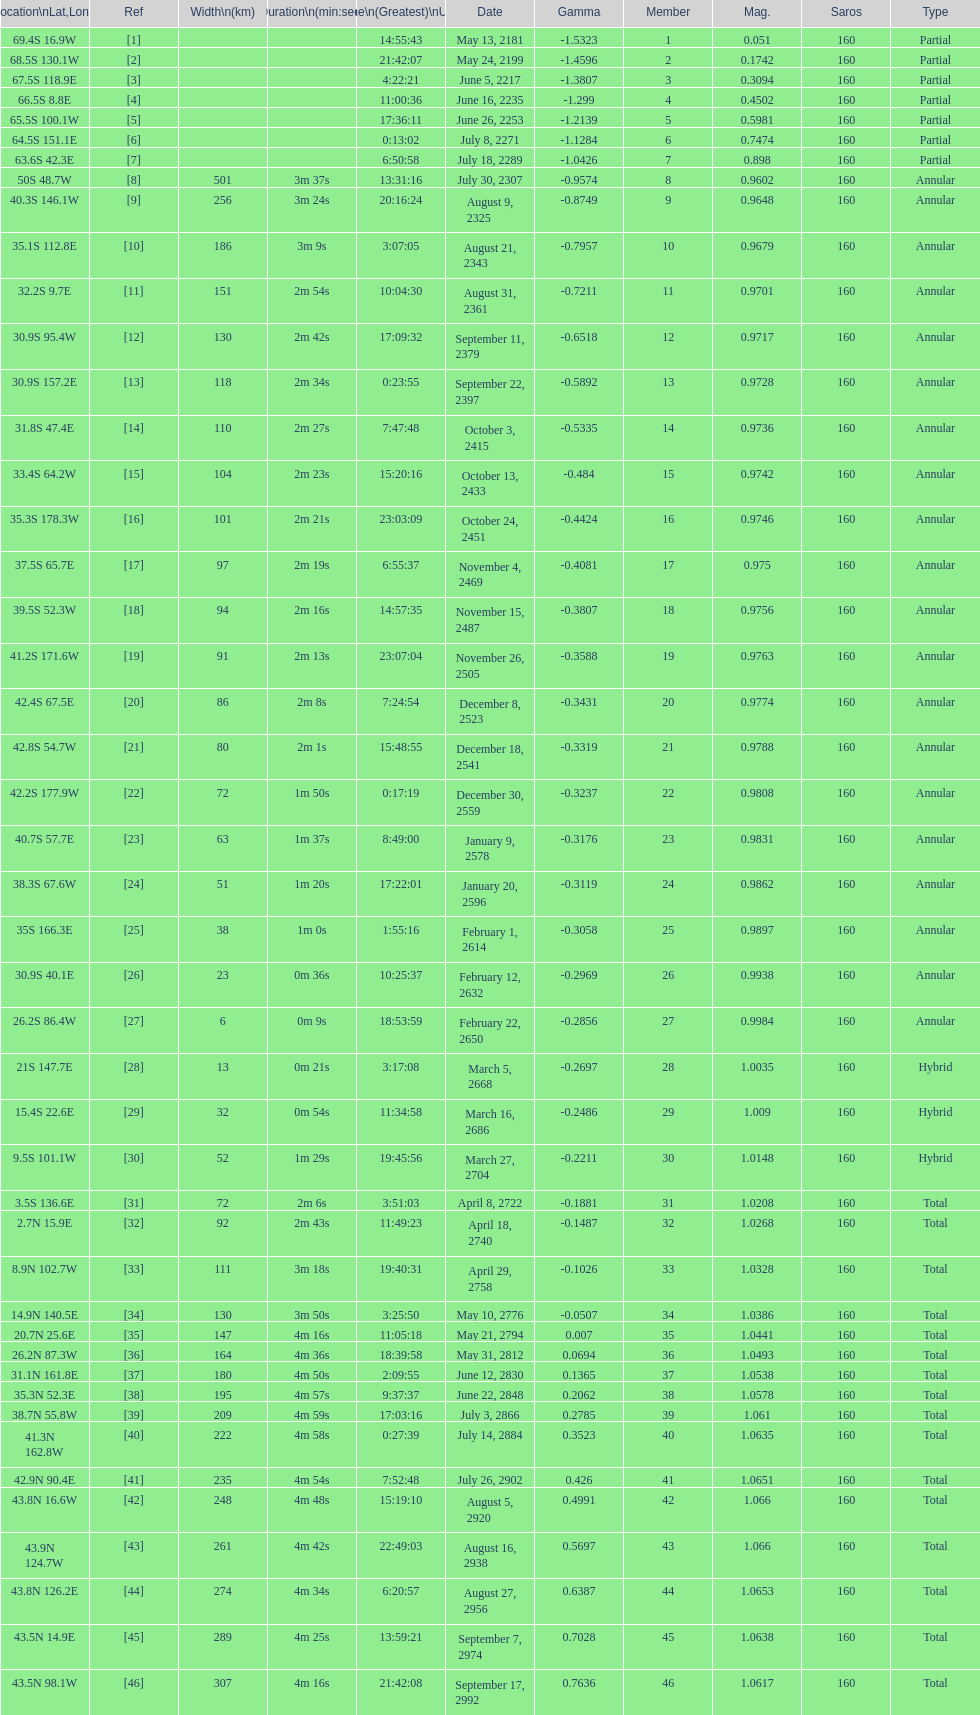Parse the full table. {'header': ['Location\\nLat,Long', 'Ref', 'Width\\n(km)', 'Duration\\n(min:sec)', 'Time\\n(Greatest)\\nUTC', 'Date', 'Gamma', 'Member', 'Mag.', 'Saros', 'Type'], 'rows': [['69.4S 16.9W', '[1]', '', '', '14:55:43', 'May 13, 2181', '-1.5323', '1', '0.051', '160', 'Partial'], ['68.5S 130.1W', '[2]', '', '', '21:42:07', 'May 24, 2199', '-1.4596', '2', '0.1742', '160', 'Partial'], ['67.5S 118.9E', '[3]', '', '', '4:22:21', 'June 5, 2217', '-1.3807', '3', '0.3094', '160', 'Partial'], ['66.5S 8.8E', '[4]', '', '', '11:00:36', 'June 16, 2235', '-1.299', '4', '0.4502', '160', 'Partial'], ['65.5S 100.1W', '[5]', '', '', '17:36:11', 'June 26, 2253', '-1.2139', '5', '0.5981', '160', 'Partial'], ['64.5S 151.1E', '[6]', '', '', '0:13:02', 'July 8, 2271', '-1.1284', '6', '0.7474', '160', 'Partial'], ['63.6S 42.3E', '[7]', '', '', '6:50:58', 'July 18, 2289', '-1.0426', '7', '0.898', '160', 'Partial'], ['50S 48.7W', '[8]', '501', '3m 37s', '13:31:16', 'July 30, 2307', '-0.9574', '8', '0.9602', '160', 'Annular'], ['40.3S 146.1W', '[9]', '256', '3m 24s', '20:16:24', 'August 9, 2325', '-0.8749', '9', '0.9648', '160', 'Annular'], ['35.1S 112.8E', '[10]', '186', '3m 9s', '3:07:05', 'August 21, 2343', '-0.7957', '10', '0.9679', '160', 'Annular'], ['32.2S 9.7E', '[11]', '151', '2m 54s', '10:04:30', 'August 31, 2361', '-0.7211', '11', '0.9701', '160', 'Annular'], ['30.9S 95.4W', '[12]', '130', '2m 42s', '17:09:32', 'September 11, 2379', '-0.6518', '12', '0.9717', '160', 'Annular'], ['30.9S 157.2E', '[13]', '118', '2m 34s', '0:23:55', 'September 22, 2397', '-0.5892', '13', '0.9728', '160', 'Annular'], ['31.8S 47.4E', '[14]', '110', '2m 27s', '7:47:48', 'October 3, 2415', '-0.5335', '14', '0.9736', '160', 'Annular'], ['33.4S 64.2W', '[15]', '104', '2m 23s', '15:20:16', 'October 13, 2433', '-0.484', '15', '0.9742', '160', 'Annular'], ['35.3S 178.3W', '[16]', '101', '2m 21s', '23:03:09', 'October 24, 2451', '-0.4424', '16', '0.9746', '160', 'Annular'], ['37.5S 65.7E', '[17]', '97', '2m 19s', '6:55:37', 'November 4, 2469', '-0.4081', '17', '0.975', '160', 'Annular'], ['39.5S 52.3W', '[18]', '94', '2m 16s', '14:57:35', 'November 15, 2487', '-0.3807', '18', '0.9756', '160', 'Annular'], ['41.2S 171.6W', '[19]', '91', '2m 13s', '23:07:04', 'November 26, 2505', '-0.3588', '19', '0.9763', '160', 'Annular'], ['42.4S 67.5E', '[20]', '86', '2m 8s', '7:24:54', 'December 8, 2523', '-0.3431', '20', '0.9774', '160', 'Annular'], ['42.8S 54.7W', '[21]', '80', '2m 1s', '15:48:55', 'December 18, 2541', '-0.3319', '21', '0.9788', '160', 'Annular'], ['42.2S 177.9W', '[22]', '72', '1m 50s', '0:17:19', 'December 30, 2559', '-0.3237', '22', '0.9808', '160', 'Annular'], ['40.7S 57.7E', '[23]', '63', '1m 37s', '8:49:00', 'January 9, 2578', '-0.3176', '23', '0.9831', '160', 'Annular'], ['38.3S 67.6W', '[24]', '51', '1m 20s', '17:22:01', 'January 20, 2596', '-0.3119', '24', '0.9862', '160', 'Annular'], ['35S 166.3E', '[25]', '38', '1m 0s', '1:55:16', 'February 1, 2614', '-0.3058', '25', '0.9897', '160', 'Annular'], ['30.9S 40.1E', '[26]', '23', '0m 36s', '10:25:37', 'February 12, 2632', '-0.2969', '26', '0.9938', '160', 'Annular'], ['26.2S 86.4W', '[27]', '6', '0m 9s', '18:53:59', 'February 22, 2650', '-0.2856', '27', '0.9984', '160', 'Annular'], ['21S 147.7E', '[28]', '13', '0m 21s', '3:17:08', 'March 5, 2668', '-0.2697', '28', '1.0035', '160', 'Hybrid'], ['15.4S 22.6E', '[29]', '32', '0m 54s', '11:34:58', 'March 16, 2686', '-0.2486', '29', '1.009', '160', 'Hybrid'], ['9.5S 101.1W', '[30]', '52', '1m 29s', '19:45:56', 'March 27, 2704', '-0.2211', '30', '1.0148', '160', 'Hybrid'], ['3.5S 136.6E', '[31]', '72', '2m 6s', '3:51:03', 'April 8, 2722', '-0.1881', '31', '1.0208', '160', 'Total'], ['2.7N 15.9E', '[32]', '92', '2m 43s', '11:49:23', 'April 18, 2740', '-0.1487', '32', '1.0268', '160', 'Total'], ['8.9N 102.7W', '[33]', '111', '3m 18s', '19:40:31', 'April 29, 2758', '-0.1026', '33', '1.0328', '160', 'Total'], ['14.9N 140.5E', '[34]', '130', '3m 50s', '3:25:50', 'May 10, 2776', '-0.0507', '34', '1.0386', '160', 'Total'], ['20.7N 25.6E', '[35]', '147', '4m 16s', '11:05:18', 'May 21, 2794', '0.007', '35', '1.0441', '160', 'Total'], ['26.2N 87.3W', '[36]', '164', '4m 36s', '18:39:58', 'May 31, 2812', '0.0694', '36', '1.0493', '160', 'Total'], ['31.1N 161.8E', '[37]', '180', '4m 50s', '2:09:55', 'June 12, 2830', '0.1365', '37', '1.0538', '160', 'Total'], ['35.3N 52.3E', '[38]', '195', '4m 57s', '9:37:37', 'June 22, 2848', '0.2062', '38', '1.0578', '160', 'Total'], ['38.7N 55.8W', '[39]', '209', '4m 59s', '17:03:16', 'July 3, 2866', '0.2785', '39', '1.061', '160', 'Total'], ['41.3N 162.8W', '[40]', '222', '4m 58s', '0:27:39', 'July 14, 2884', '0.3523', '40', '1.0635', '160', 'Total'], ['42.9N 90.4E', '[41]', '235', '4m 54s', '7:52:48', 'July 26, 2902', '0.426', '41', '1.0651', '160', 'Total'], ['43.8N 16.6W', '[42]', '248', '4m 48s', '15:19:10', 'August 5, 2920', '0.4991', '42', '1.066', '160', 'Total'], ['43.9N 124.7W', '[43]', '261', '4m 42s', '22:49:03', 'August 16, 2938', '0.5697', '43', '1.066', '160', 'Total'], ['43.8N 126.2E', '[44]', '274', '4m 34s', '6:20:57', 'August 27, 2956', '0.6387', '44', '1.0653', '160', 'Total'], ['43.5N 14.9E', '[45]', '289', '4m 25s', '13:59:21', 'September 7, 2974', '0.7028', '45', '1.0638', '160', 'Total'], ['43.5N 98.1W', '[46]', '307', '4m 16s', '21:42:08', 'September 17, 2992', '0.7636', '46', '1.0617', '160', 'Total']]} How long did 18 last? 2m 16s. 